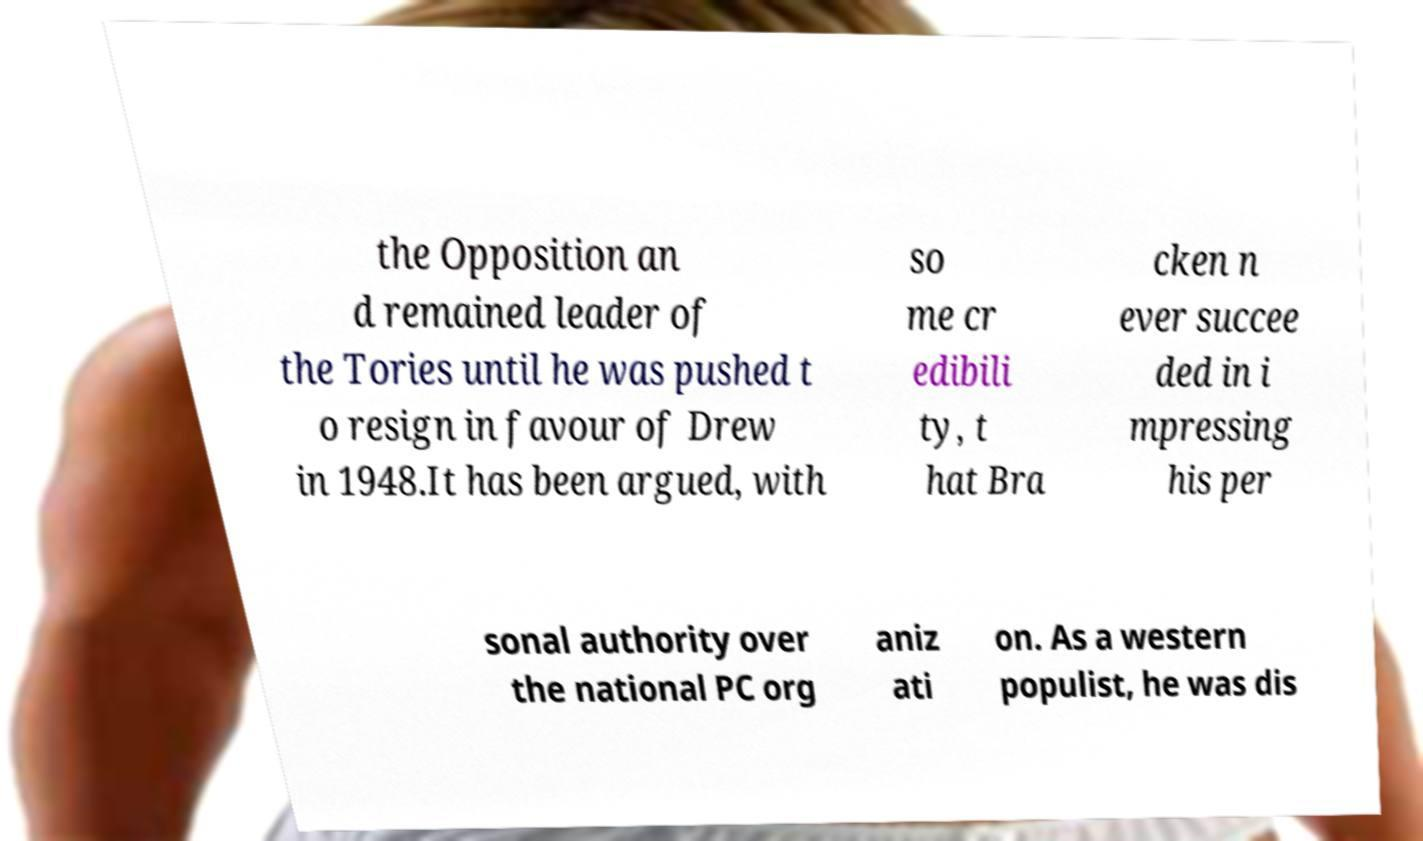Could you extract and type out the text from this image? the Opposition an d remained leader of the Tories until he was pushed t o resign in favour of Drew in 1948.It has been argued, with so me cr edibili ty, t hat Bra cken n ever succee ded in i mpressing his per sonal authority over the national PC org aniz ati on. As a western populist, he was dis 